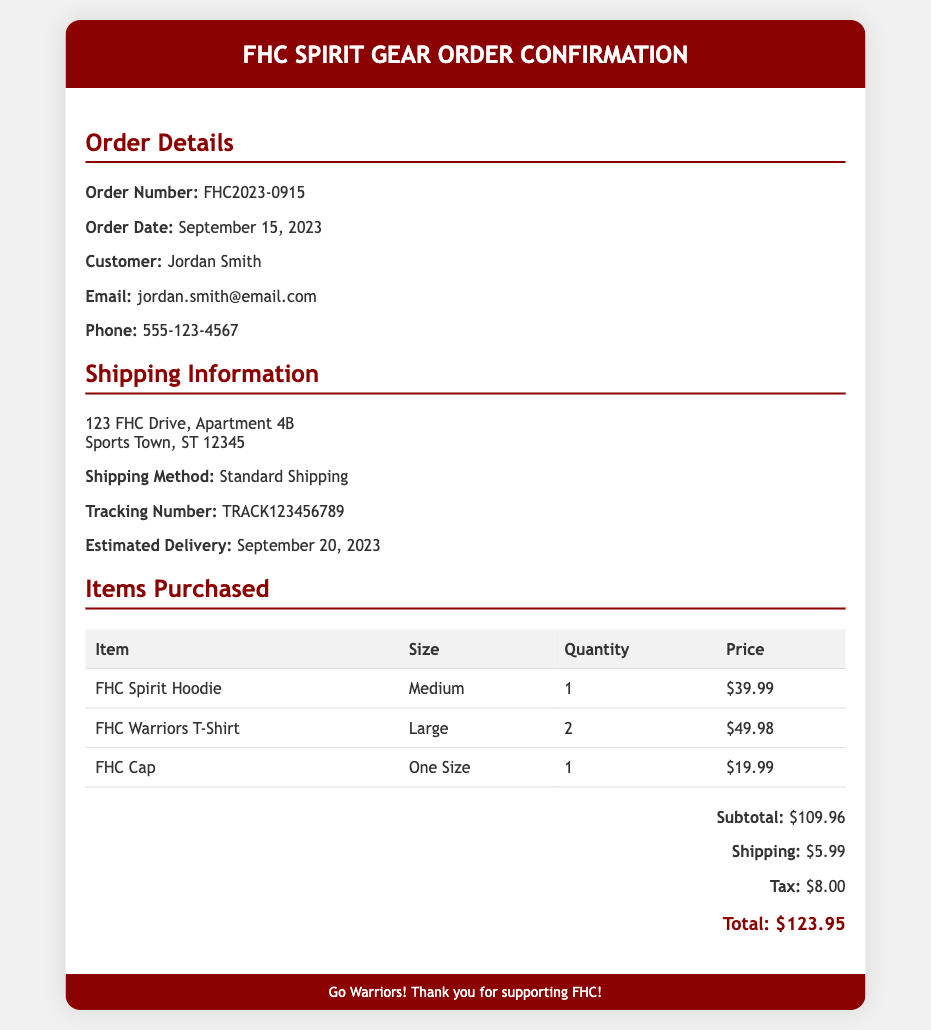what is the order number? The order number is specifically listed in the order details section of the document.
Answer: FHC2023-0915 who is the customer? The customer's name is provided in the order details section.
Answer: Jordan Smith what is the shipping address? The shipping address is found in the shipping information section of the document.
Answer: 123 FHC Drive, Apartment 4B what is the estimated delivery date? The estimated delivery date for the order is mentioned in the shipping information section.
Answer: September 20, 2023 how many FHC Warriors T-Shirts were purchased? The quantity of FHC Warriors T-Shirts is listed in the items purchased table.
Answer: 2 what is the subtotal amount for the order? The subtotal amount is provided clearly in the totals section of the document.
Answer: $109.96 what shipping method was used? The shipping method is detailed in the shipping information section of the document.
Answer: Standard Shipping how much tax was paid on the order? The tax amount is listed in the totals section of the document.
Answer: $8.00 what is the total amount due? The total amount due is calculated and shown in the totals section of the document.
Answer: $123.95 